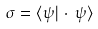Convert formula to latex. <formula><loc_0><loc_0><loc_500><loc_500>\sigma = \langle \psi | \cdot \, \psi \rangle</formula> 